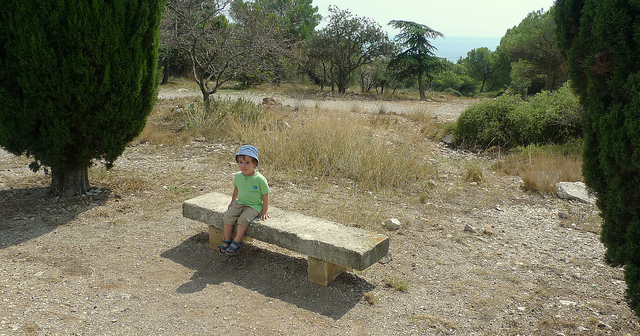<image>What shadow is cast on the tree? It is ambiguous what shadow is cast on the tree. It is possibly a tree shadow, other tree shadow, or a boat. It might also be that there is no shadow casted on the tree. What shadow is cast on the tree? There is no shadow cast on the tree. 